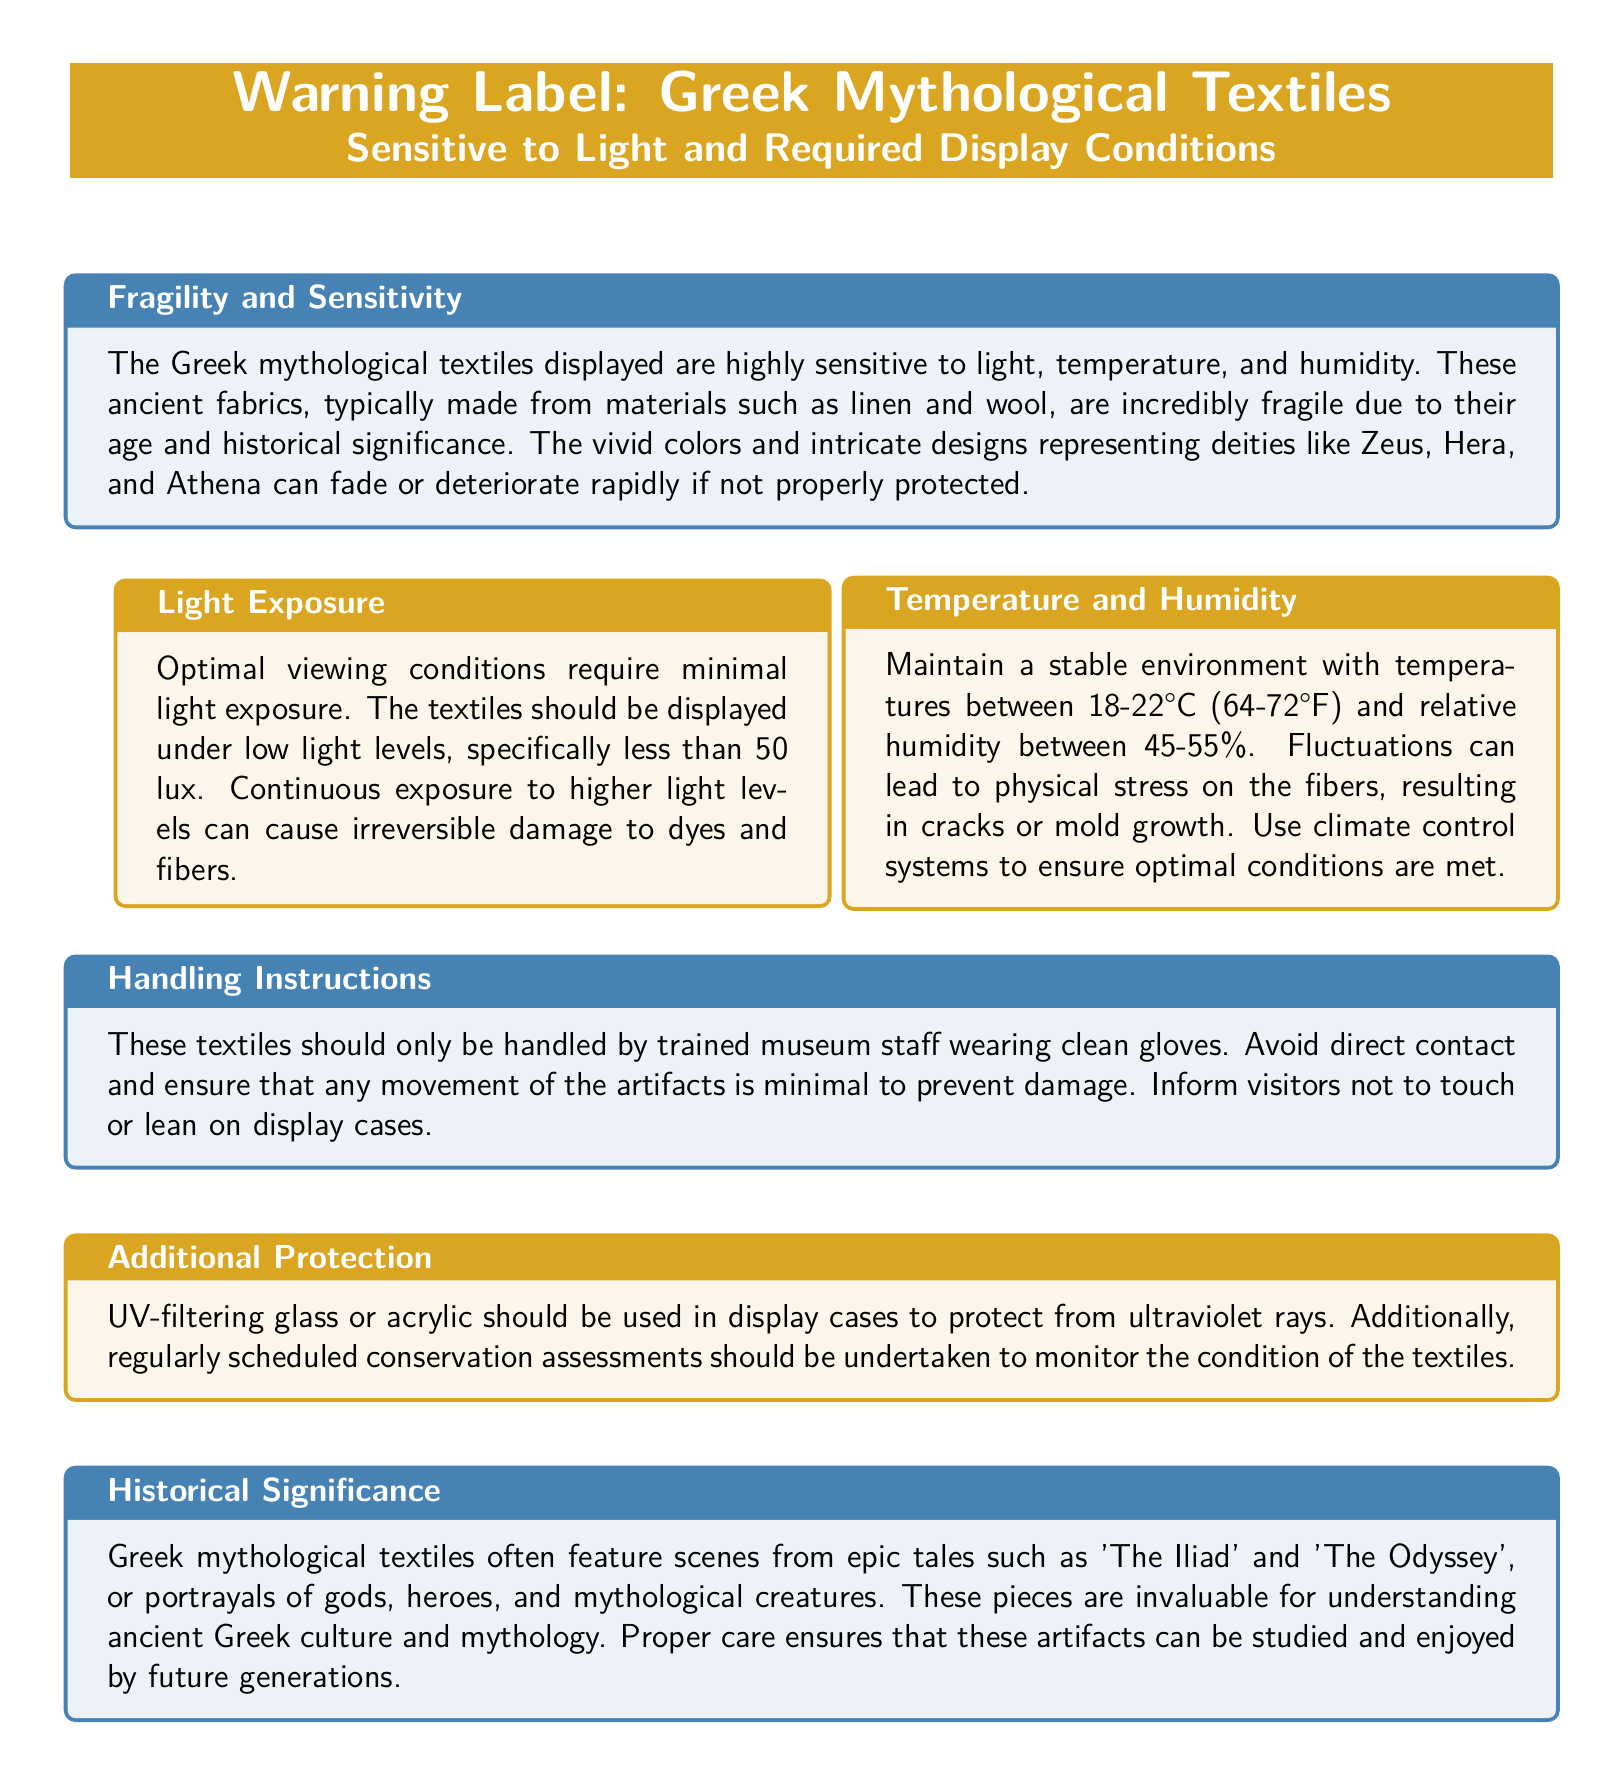What materials are the Greek mythological textiles made from? The document specifies that the textiles are typically made from linen and wool.
Answer: linen and wool What is the optimal light exposure for the textiles? The document indicates that the textiles should be displayed under low light levels, specifically less than 50 lux.
Answer: less than 50 lux What temperature range is required for the textiles? The document states that the required temperature range is between 18-22°C (64-72°F).
Answer: 18-22°C (64-72°F) Who should handle the textiles? The document notes that these textiles should only be handled by trained museum staff wearing clean gloves.
Answer: trained museum staff What is the purpose of using UV-filtering glass in display cases? The document explains that UV-filtering glass or acrylic should be used to protect from ultraviolet rays.
Answer: protect from ultraviolet rays How does fluctuating humidity affect the textiles? The document mentions that fluctuations can lead to physical stress on the fibers, resulting in cracks or mold growth.
Answer: cracks or mold growth What types of scenes do Greek mythological textiles often feature? The document states that these textiles often feature scenes from epic tales such as 'The Iliad' and 'The Odyssey'.
Answer: 'The Iliad' and 'The Odyssey' What is the purpose of regularly scheduled conservation assessments? The document indicates that these assessments are undertaken to monitor the condition of the textiles.
Answer: monitor the condition What is the humidity range for displaying the textiles? The document specifies that the relative humidity should be between 45-55%.
Answer: 45-55% 